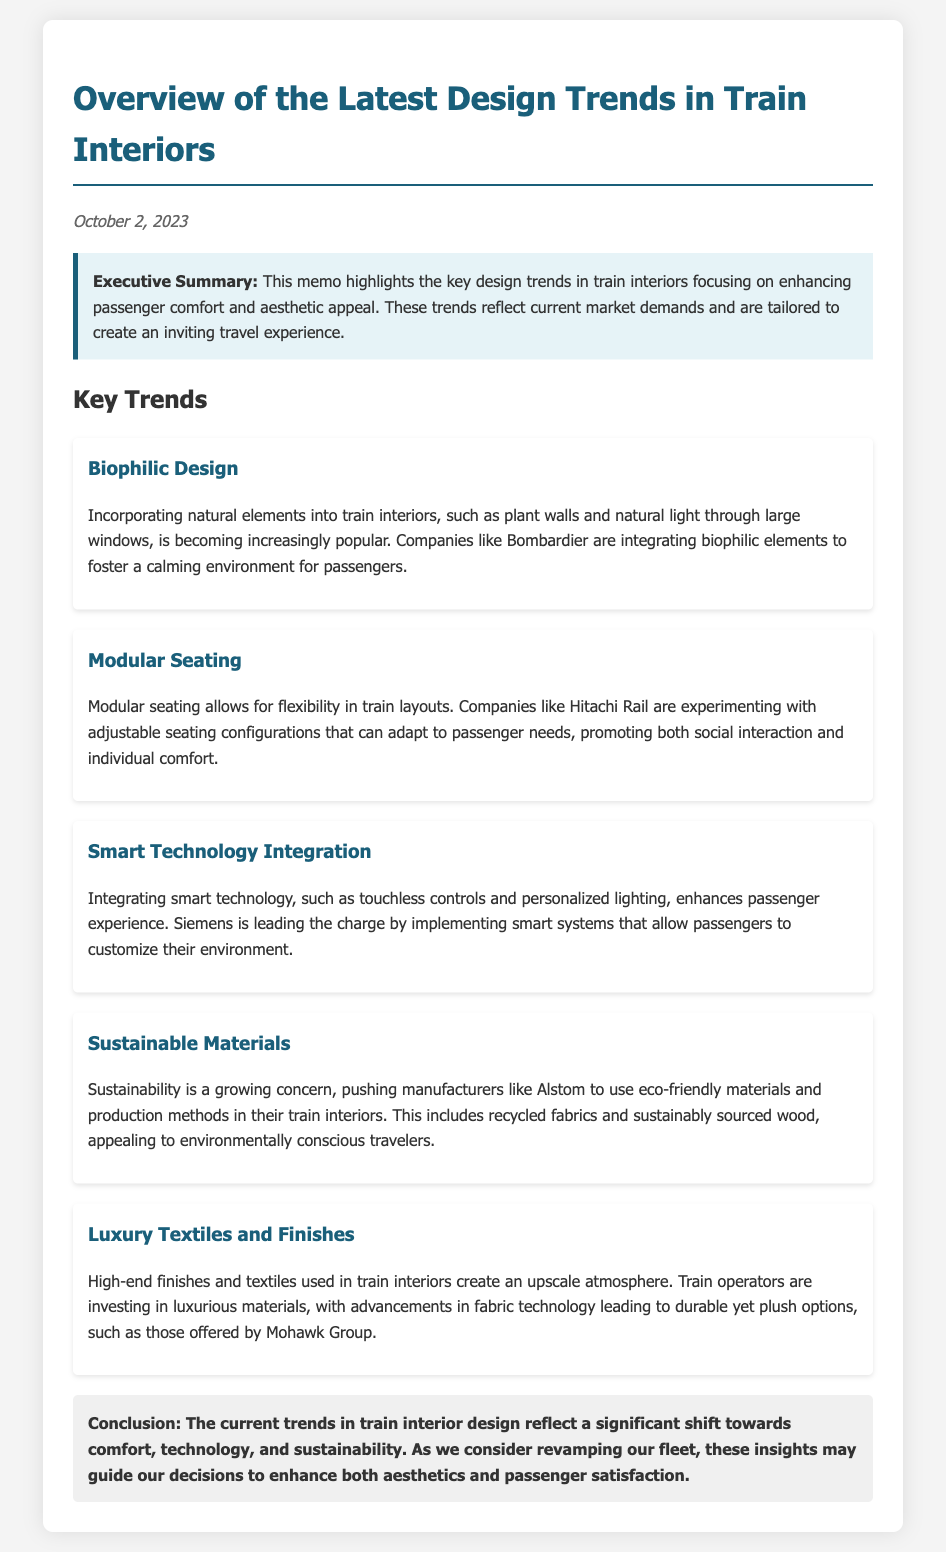What is the date of the memo? The date of the memo is stated at the top, indicating when it was written.
Answer: October 2, 2023 What design trend involves incorporating natural elements? This question refers to one of the key trends listed in the memo.
Answer: Biophilic Design Which company is mentioned for integrating smart technology? The document specifies companies associated with different trends, including smart technology.
Answer: Siemens What material type is emphasized for sustainability? The memo discusses materials that are eco-friendly as part of a trending focus on sustainability.
Answer: Sustainable materials What seating feature promotes flexibility? This refers to the trend that allows for adaptable train layouts to enhance passenger comfort.
Answer: Modular seating Which company uses luxury textiles and finishes? The document provides examples of companies leading in particular trends, including luxury textiles.
Answer: Mohawk Group What element is stressed in the conclusion? This part of the memo summarizes the overarching themes and shifts in train interior designs.
Answer: Comfort, technology, and sustainability Which company is known for biophilic elements? Refers to the mention of a specific company associated with a particular design trend.
Answer: Bombardier What is the main focus of the executive summary? This part provides a brief overview of the memo’s intent and highlights key aspects of the design trends discussed.
Answer: Enhancing passenger comfort and aesthetic appeal 